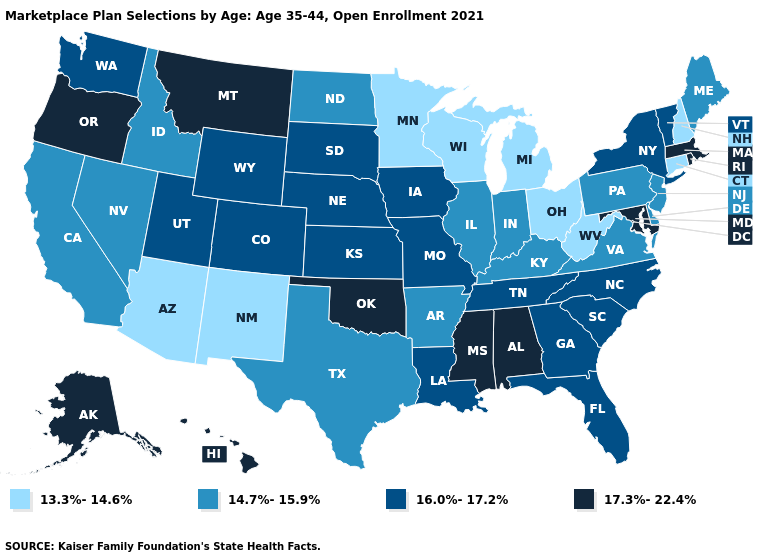What is the highest value in states that border Mississippi?
Quick response, please. 17.3%-22.4%. Name the states that have a value in the range 14.7%-15.9%?
Give a very brief answer. Arkansas, California, Delaware, Idaho, Illinois, Indiana, Kentucky, Maine, Nevada, New Jersey, North Dakota, Pennsylvania, Texas, Virginia. What is the lowest value in the USA?
Answer briefly. 13.3%-14.6%. What is the value of Louisiana?
Quick response, please. 16.0%-17.2%. Among the states that border Utah , does Idaho have the highest value?
Be succinct. No. Does the map have missing data?
Short answer required. No. Name the states that have a value in the range 17.3%-22.4%?
Write a very short answer. Alabama, Alaska, Hawaii, Maryland, Massachusetts, Mississippi, Montana, Oklahoma, Oregon, Rhode Island. Does Utah have the lowest value in the USA?
Concise answer only. No. Name the states that have a value in the range 17.3%-22.4%?
Write a very short answer. Alabama, Alaska, Hawaii, Maryland, Massachusetts, Mississippi, Montana, Oklahoma, Oregon, Rhode Island. What is the value of Alaska?
Concise answer only. 17.3%-22.4%. Which states hav the highest value in the Northeast?
Be succinct. Massachusetts, Rhode Island. Among the states that border Iowa , does Wisconsin have the highest value?
Keep it brief. No. What is the lowest value in the Northeast?
Concise answer only. 13.3%-14.6%. Which states have the lowest value in the South?
Keep it brief. West Virginia. What is the highest value in states that border Nevada?
Be succinct. 17.3%-22.4%. 